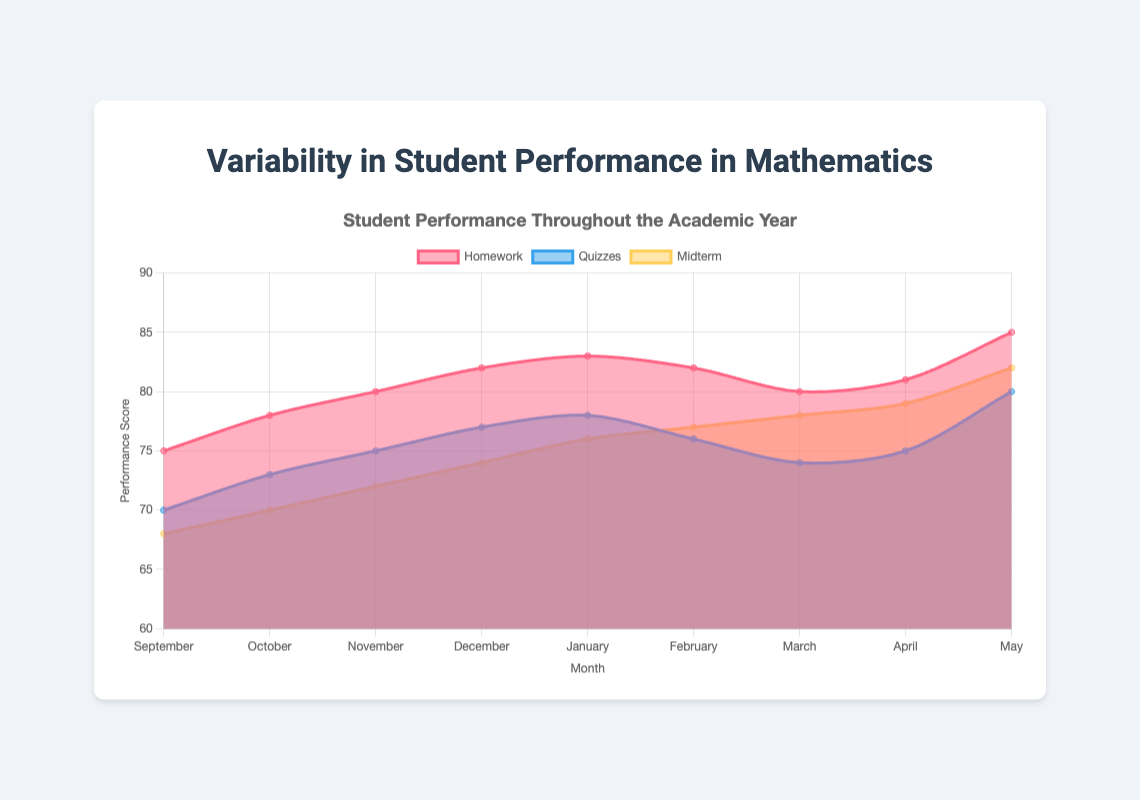What is the title of the chart? The title is located at the top of the chart and summarizes the visual data representation.
Answer: Variability in Student Performance in Mathematics Throughout the Academic Year What is the performance score for homework in November? Locate November on the x-axis, then trace upward to intersect with the 'Homework' curve, and check the corresponding y-axis value.
Answer: 80 Which assessment type shows the greatest improvement from September to May? Calculate the difference between the performance scores for September and May for each assessment type: Homework (85-75=10), Quizzes (80-70=10), Midterm (82-68=14).
Answer: Midterm How does the performance in quizzes in February compare to January? Check the performance scores for quizzes in January and February from the chart, then compare them.
Answer: It decreased Which month shows the highest performance score in midterms? Identify the peak value of the midterm curve (yellow) on the chart and note its corresponding month.
Answer: May Is there a month where the performance scores of quizzes and midterms are equal? Look for any point where the quiz and midterm curves intersect on the chart and identify the corresponding month.
Answer: No What is the average performance score for homework across all months? Add all homework scores and divide by the number of months (75+78+80+82+83+82+80+81+85)/9.
Answer: 80.7 By how much does the performance in midterms increase from October to November? Subtract the midterm score of October from November (72-70).
Answer: 2 During which month does the homework curve surpass a performance score of 80? Find the month(s) where the 'Homework' curve crosses above the score of 80 on the y-axis.
Answer: December How does the variability in performance scores for quizzes compare to that of midterms throughout the academic year? Observe the spread and fluctuations of both quiz and midterm curves on the chart. The quiz scores show steady progression with less variation, while midterms have a noticeable increase over time.
Answer: Quizzes show less variability than midterms 